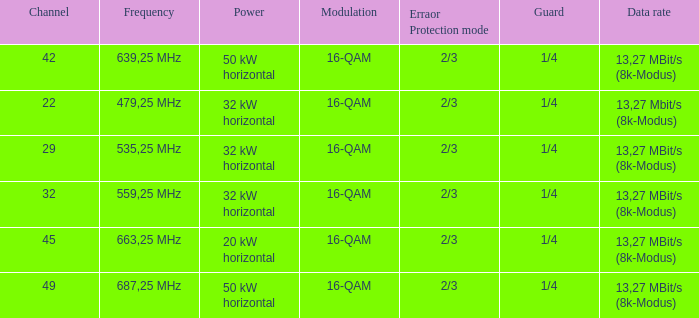On channel 32, when the power is 32 kW horizontal, what is the modulation? 16-QAM. Could you help me parse every detail presented in this table? {'header': ['Channel', 'Frequency', 'Power', 'Modulation', 'Erraor Protection mode', 'Guard', 'Data rate'], 'rows': [['42', '639,25 MHz', '50 kW horizontal', '16-QAM', '2/3', '1/4', '13,27 MBit/s (8k-Modus)'], ['22', '479,25 MHz', '32 kW horizontal', '16-QAM', '2/3', '1/4', '13,27 Mbit/s (8k-Modus)'], ['29', '535,25 MHz', '32 kW horizontal', '16-QAM', '2/3', '1/4', '13,27 MBit/s (8k-Modus)'], ['32', '559,25 MHz', '32 kW horizontal', '16-QAM', '2/3', '1/4', '13,27 MBit/s (8k-Modus)'], ['45', '663,25 MHz', '20 kW horizontal', '16-QAM', '2/3', '1/4', '13,27 MBit/s (8k-Modus)'], ['49', '687,25 MHz', '50 kW horizontal', '16-QAM', '2/3', '1/4', '13,27 MBit/s (8k-Modus)']]} 